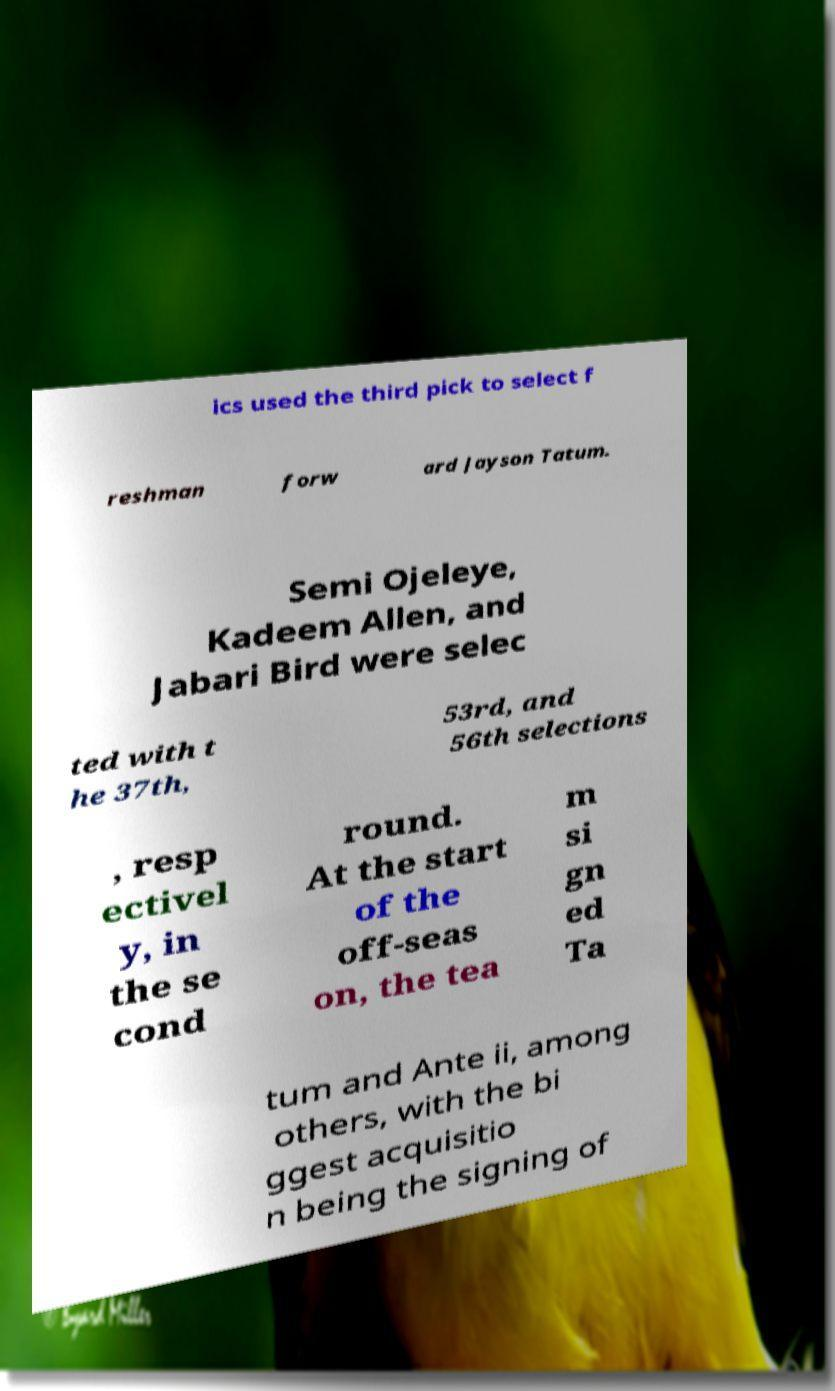Could you assist in decoding the text presented in this image and type it out clearly? ics used the third pick to select f reshman forw ard Jayson Tatum. Semi Ojeleye, Kadeem Allen, and Jabari Bird were selec ted with t he 37th, 53rd, and 56th selections , resp ectivel y, in the se cond round. At the start of the off-seas on, the tea m si gn ed Ta tum and Ante ii, among others, with the bi ggest acquisitio n being the signing of 